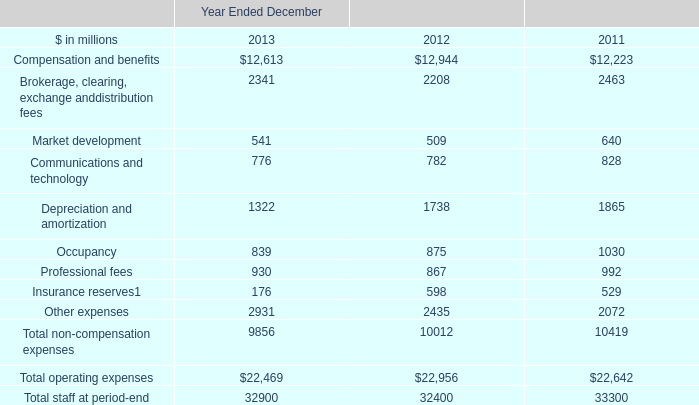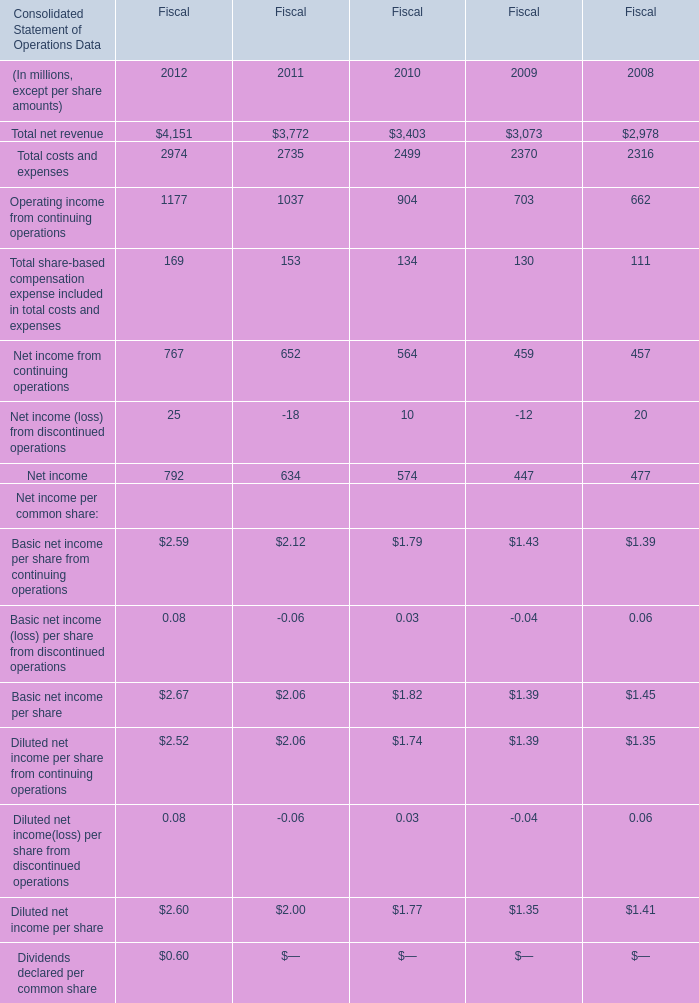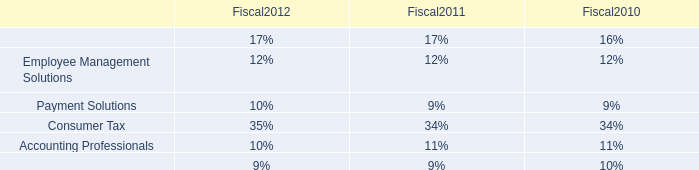What is the average amount of Operating income from continuing operations of Fiscal 2012, and Other expenses of Year Ended December 2011 ? 
Computations: ((1177.0 + 2072.0) / 2)
Answer: 1624.5. 